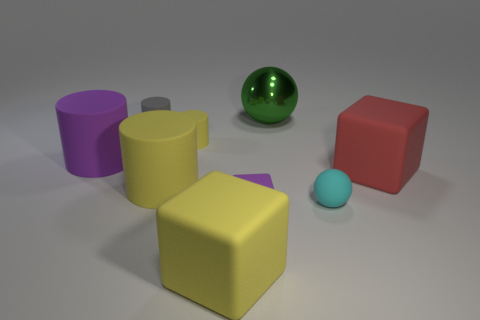Is the cyan sphere the same size as the red rubber thing?
Ensure brevity in your answer.  No. Does the big cylinder in front of the big purple rubber object have the same color as the ball in front of the large yellow matte cylinder?
Ensure brevity in your answer.  No. Does the big green thing have the same shape as the small cyan matte object?
Your answer should be very brief. Yes. Does the cylinder that is to the left of the gray cylinder have the same material as the large yellow cube?
Provide a short and direct response. Yes. There is a big object that is behind the big red matte object and in front of the big green shiny object; what shape is it?
Provide a short and direct response. Cylinder. Are there any large objects that are on the left side of the block right of the small purple object?
Offer a very short reply. Yes. What number of other objects are there of the same material as the large ball?
Give a very brief answer. 0. There is a large yellow matte thing that is behind the rubber sphere; is it the same shape as the big matte object that is behind the red thing?
Offer a terse response. Yes. Does the tiny yellow thing have the same material as the green sphere?
Keep it short and to the point. No. There is a yellow matte cylinder in front of the large object that is to the right of the sphere that is behind the gray object; what is its size?
Provide a succinct answer. Large. 